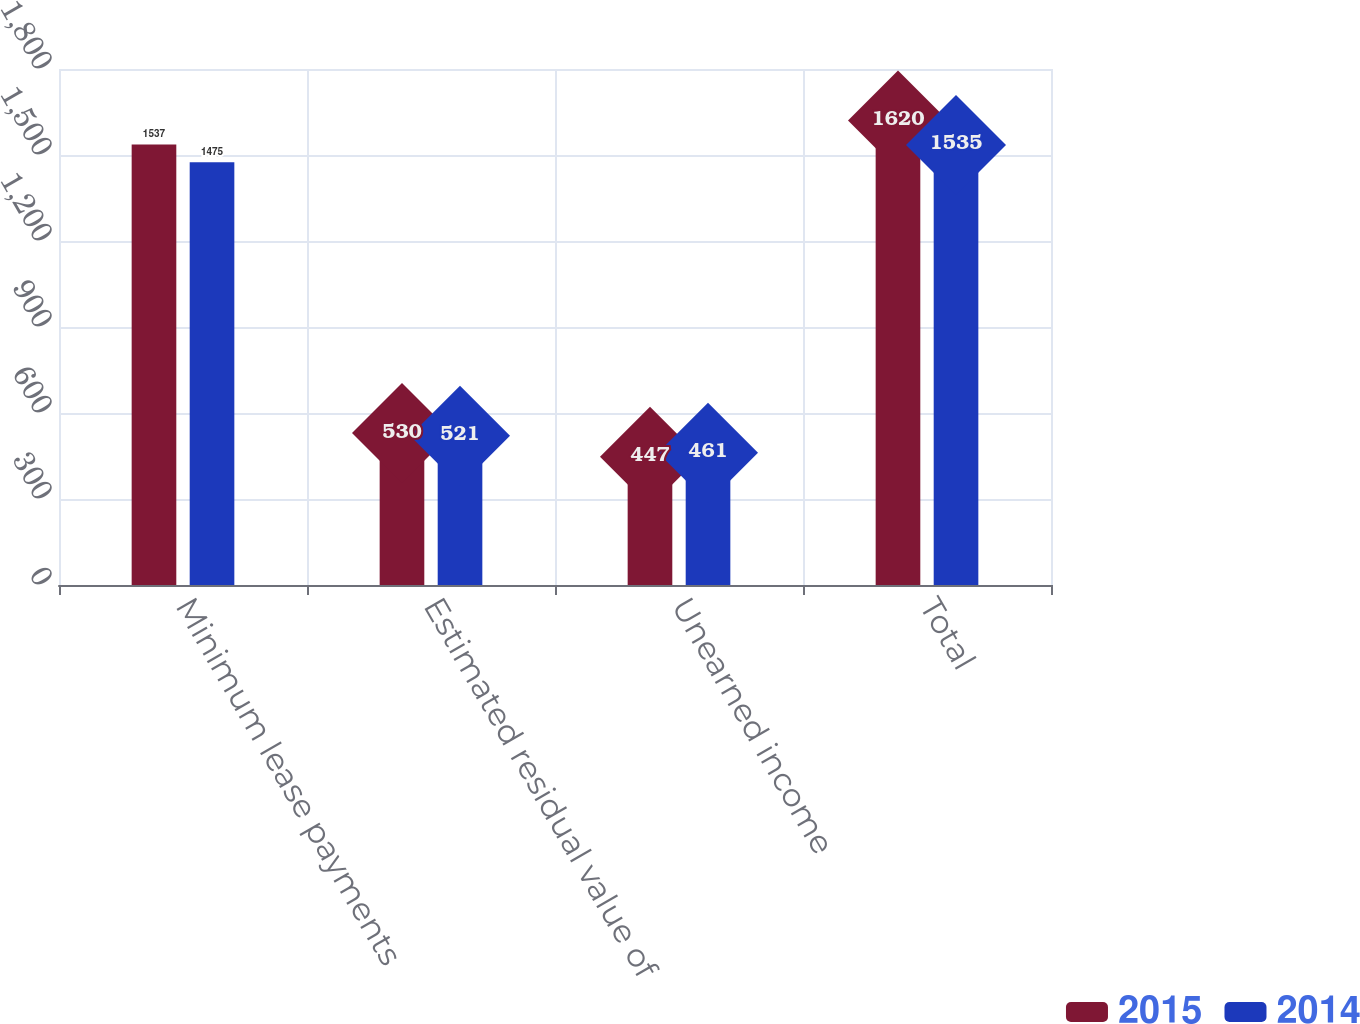Convert chart. <chart><loc_0><loc_0><loc_500><loc_500><stacked_bar_chart><ecel><fcel>Minimum lease payments<fcel>Estimated residual value of<fcel>Unearned income<fcel>Total<nl><fcel>2015<fcel>1537<fcel>530<fcel>447<fcel>1620<nl><fcel>2014<fcel>1475<fcel>521<fcel>461<fcel>1535<nl></chart> 